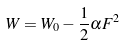<formula> <loc_0><loc_0><loc_500><loc_500>W = W _ { 0 } - \frac { 1 } { 2 } \alpha F ^ { 2 }</formula> 